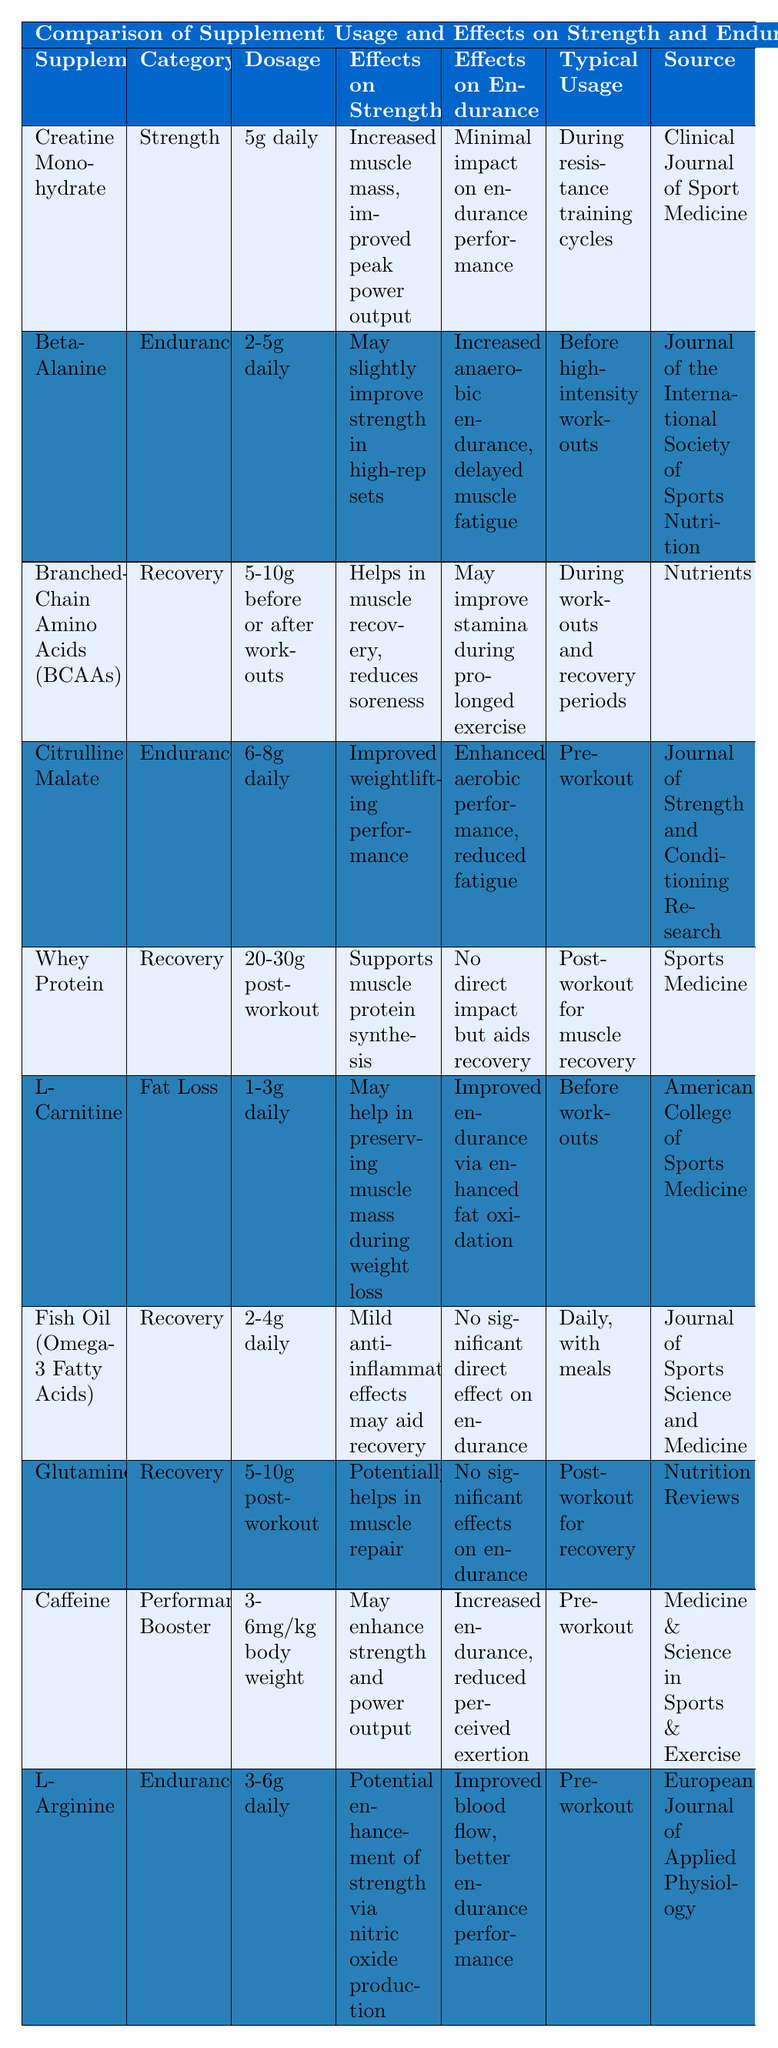What is the typical dosage of Citrulline Malate? The table specifies that Citrulline Malate has a dosage of 6-8g daily.
Answer: 6-8g daily Which supplement is categorized as Recovery and has no significant effects on endurance? The table lists Glutamine under the Recovery category, and it states that it has no significant effects on endurance.
Answer: Glutamine Does Whey Protein have a direct impact on endurance? The table indicates that Whey Protein has no direct impact on endurance and aids in recovery instead.
Answer: No Which supplement is used before workouts and improves endurance through fat oxidation? The table shows that L-Carnitine is taken before workouts and is reported to improve endurance via enhanced fat oxidation.
Answer: L-Carnitine What effect does Caffeine have on both strength and endurance? According to the table, Caffeine may enhance strength and power output while also increasing endurance and reducing perceived exertion.
Answer: Enhances strength and endurance What is the dosage range for Beta-Alanine? The table states that Beta-Alanine can be taken in dosages ranging from 2-5g daily.
Answer: 2-5g daily How many supplements listed have a primary focus on strength? The table lists two supplements focused on strength: Creatine Monohydrate and Caffeine.
Answer: 2 Which supplement helps in muscle recovery and is taken before or after workouts? The table identifies Branched-Chain Amino Acids (BCAAs) as the supplement that helps in muscle recovery and is taken either before or after workouts.
Answer: Branched-Chain Amino Acids (BCAAs) What is the source for the information on Fish Oil? The table cites the Journal of Sports Science and Medicine as the source for Fish Oil's information.
Answer: Journal of Sports Science and Medicine Which supplement improves blood flow and endurance performance? According to the table, L-Arginine improves blood flow and better endurance performance.
Answer: L-Arginine What is the difference in the impact on strength between Creatine Monohydrate and Beta-Alanine? The table indicates that Creatine Monohydrate provides increased muscle mass and improved peak power, while Beta-Alanine may slightly improve strength in high-rep sets, showing that Creatine has a more significant impact on strength.
Answer: Creatine Monohydrate has a greater impact How many supplements are recommended for use before workouts? The table shows three supplements that are recommended for use before workouts: Beta-Alanine, Citrulline Malate, and L-Arginine.
Answer: 3 Is there any supplement that aids muscle recovery and might improve endurance during prolonged exercise? The table indicates that BCAAs aid in muscle recovery and may improve stamina during prolonged exercise, making it a supplement that serves both purposes.
Answer: Yes, BCAAs 